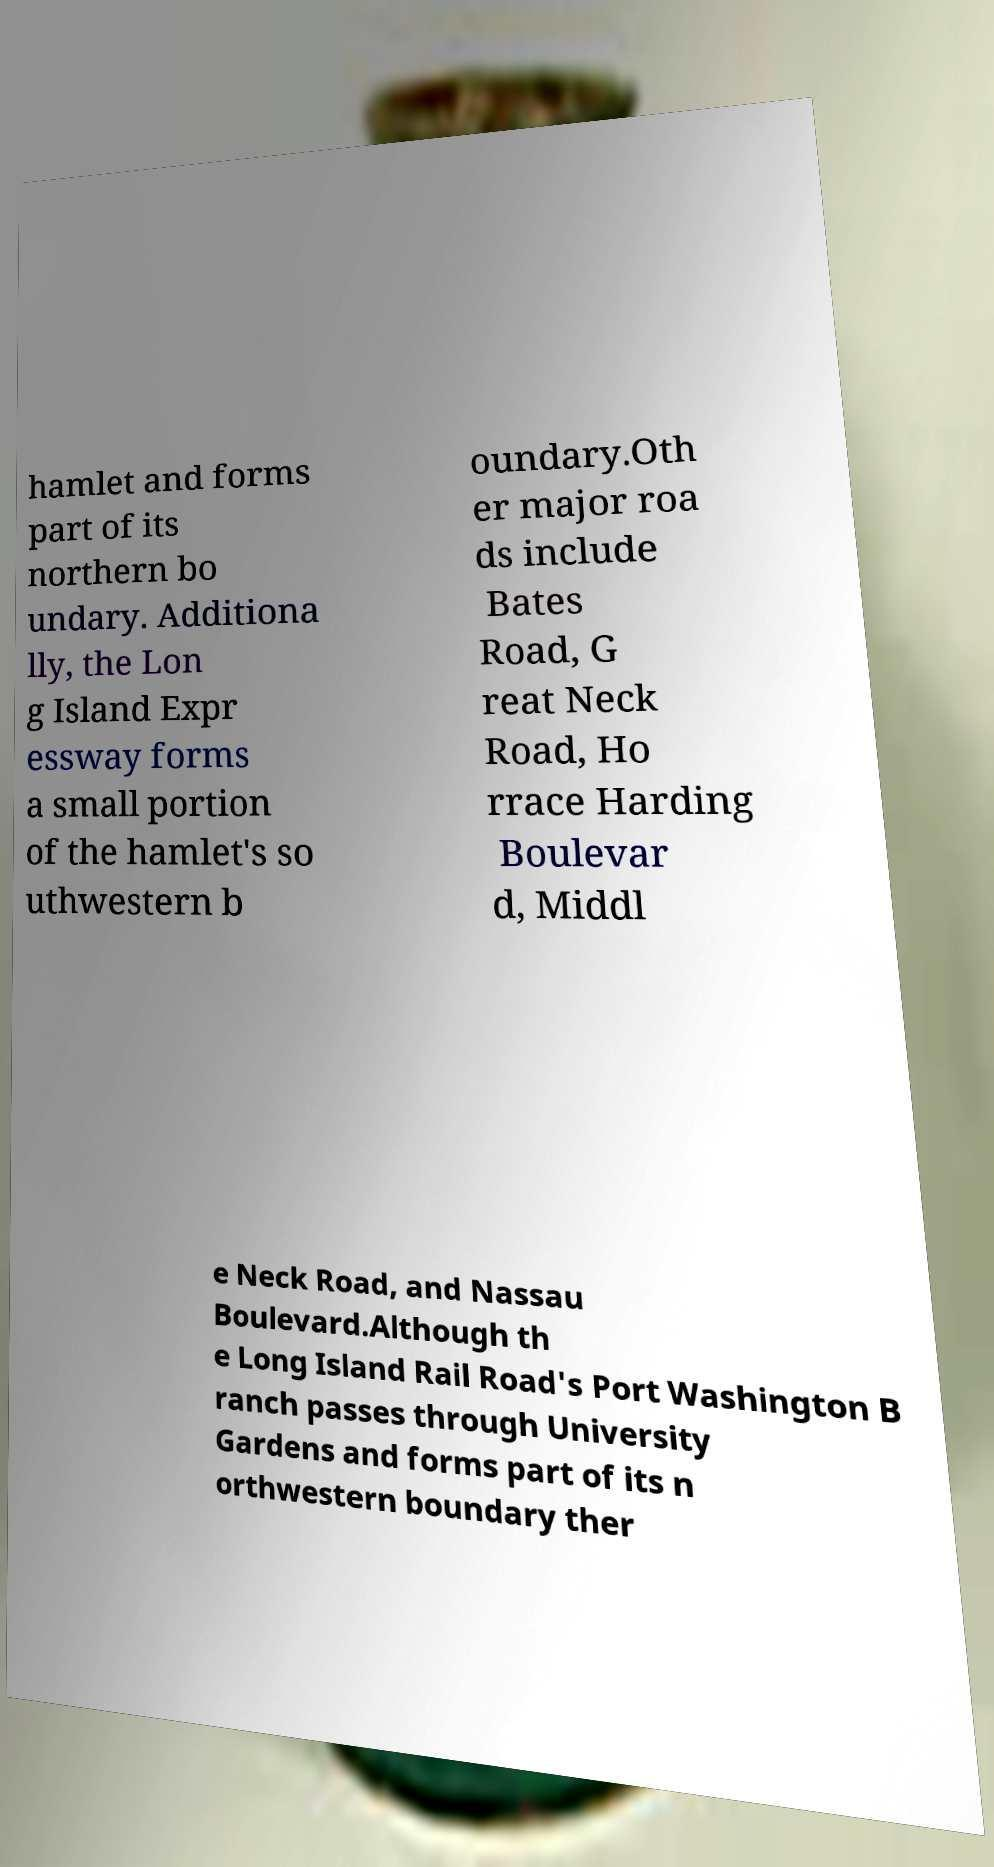Please identify and transcribe the text found in this image. hamlet and forms part of its northern bo undary. Additiona lly, the Lon g Island Expr essway forms a small portion of the hamlet's so uthwestern b oundary.Oth er major roa ds include Bates Road, G reat Neck Road, Ho rrace Harding Boulevar d, Middl e Neck Road, and Nassau Boulevard.Although th e Long Island Rail Road's Port Washington B ranch passes through University Gardens and forms part of its n orthwestern boundary ther 